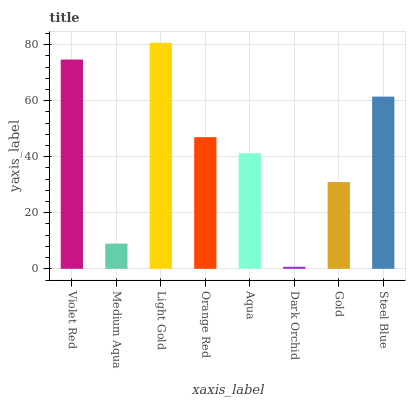Is Medium Aqua the minimum?
Answer yes or no. No. Is Medium Aqua the maximum?
Answer yes or no. No. Is Violet Red greater than Medium Aqua?
Answer yes or no. Yes. Is Medium Aqua less than Violet Red?
Answer yes or no. Yes. Is Medium Aqua greater than Violet Red?
Answer yes or no. No. Is Violet Red less than Medium Aqua?
Answer yes or no. No. Is Orange Red the high median?
Answer yes or no. Yes. Is Aqua the low median?
Answer yes or no. Yes. Is Medium Aqua the high median?
Answer yes or no. No. Is Gold the low median?
Answer yes or no. No. 